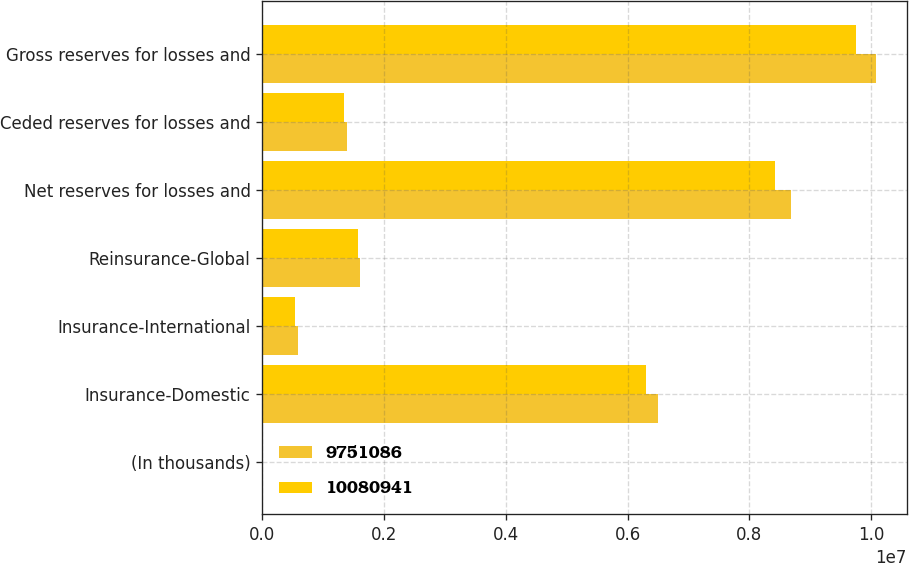Convert chart to OTSL. <chart><loc_0><loc_0><loc_500><loc_500><stacked_bar_chart><ecel><fcel>(In thousands)<fcel>Insurance-Domestic<fcel>Insurance-International<fcel>Reinsurance-Global<fcel>Net reserves for losses and<fcel>Ceded reserves for losses and<fcel>Gross reserves for losses and<nl><fcel>9.75109e+06<fcel>2013<fcel>6.4934e+06<fcel>592709<fcel>1.59769e+06<fcel>8.6838e+06<fcel>1.39714e+06<fcel>1.00809e+07<nl><fcel>1.00809e+07<fcel>2012<fcel>6.29777e+06<fcel>540769<fcel>1.57331e+06<fcel>8.41185e+06<fcel>1.33924e+06<fcel>9.75109e+06<nl></chart> 